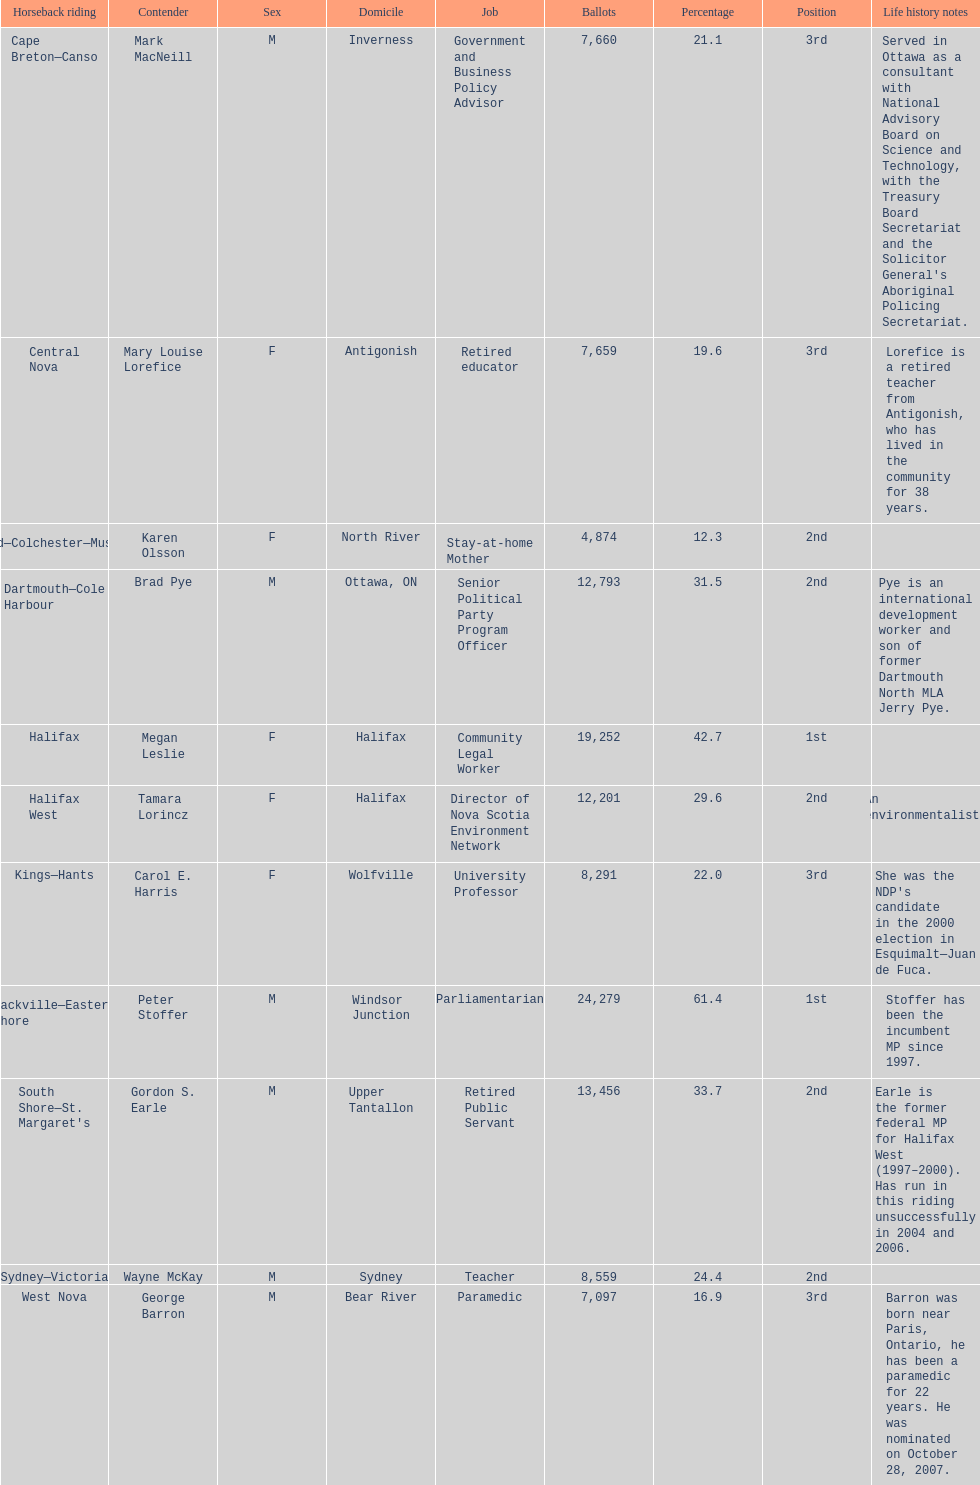How many candidates are there in total? 11. 